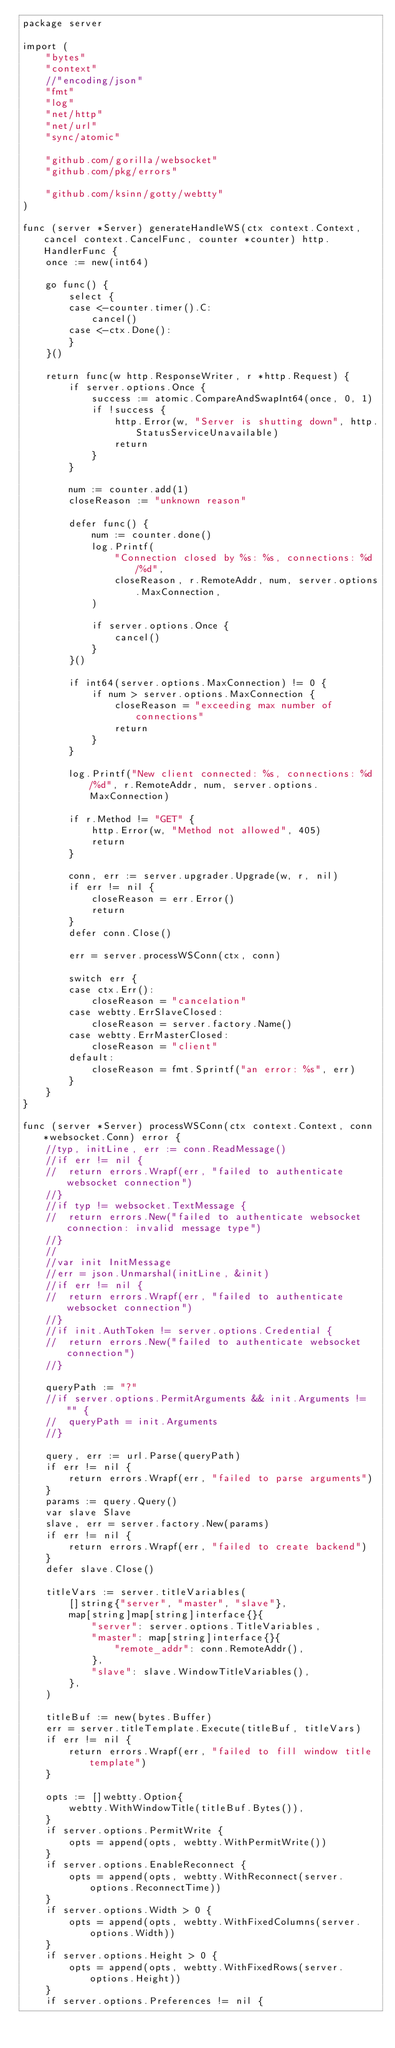Convert code to text. <code><loc_0><loc_0><loc_500><loc_500><_Go_>package server

import (
	"bytes"
	"context"
	//"encoding/json"
	"fmt"
	"log"
	"net/http"
	"net/url"
	"sync/atomic"

	"github.com/gorilla/websocket"
	"github.com/pkg/errors"

	"github.com/ksinn/gotty/webtty"
)

func (server *Server) generateHandleWS(ctx context.Context, cancel context.CancelFunc, counter *counter) http.HandlerFunc {
	once := new(int64)

	go func() {
		select {
		case <-counter.timer().C:
			cancel()
		case <-ctx.Done():
		}
	}()

	return func(w http.ResponseWriter, r *http.Request) {
		if server.options.Once {
			success := atomic.CompareAndSwapInt64(once, 0, 1)
			if !success {
				http.Error(w, "Server is shutting down", http.StatusServiceUnavailable)
				return
			}
		}

		num := counter.add(1)
		closeReason := "unknown reason"

		defer func() {
			num := counter.done()
			log.Printf(
				"Connection closed by %s: %s, connections: %d/%d",
				closeReason, r.RemoteAddr, num, server.options.MaxConnection,
			)

			if server.options.Once {
				cancel()
			}
		}()

		if int64(server.options.MaxConnection) != 0 {
			if num > server.options.MaxConnection {
				closeReason = "exceeding max number of connections"
				return
			}
		}

		log.Printf("New client connected: %s, connections: %d/%d", r.RemoteAddr, num, server.options.MaxConnection)

		if r.Method != "GET" {
			http.Error(w, "Method not allowed", 405)
			return
		}

		conn, err := server.upgrader.Upgrade(w, r, nil)
		if err != nil {
			closeReason = err.Error()
			return
		}
		defer conn.Close()

		err = server.processWSConn(ctx, conn)

		switch err {
		case ctx.Err():
			closeReason = "cancelation"
		case webtty.ErrSlaveClosed:
			closeReason = server.factory.Name()
		case webtty.ErrMasterClosed:
			closeReason = "client"
		default:
			closeReason = fmt.Sprintf("an error: %s", err)
		}
	}
}

func (server *Server) processWSConn(ctx context.Context, conn *websocket.Conn) error {
	//typ, initLine, err := conn.ReadMessage()
	//if err != nil {
	//	return errors.Wrapf(err, "failed to authenticate websocket connection")
	//}
	//if typ != websocket.TextMessage {
	//	return errors.New("failed to authenticate websocket connection: invalid message type")
	//}
	//
	//var init InitMessage
	//err = json.Unmarshal(initLine, &init)
	//if err != nil {
	//	return errors.Wrapf(err, "failed to authenticate websocket connection")
	//}
	//if init.AuthToken != server.options.Credential {
	//	return errors.New("failed to authenticate websocket connection")
	//}

	queryPath := "?"
	//if server.options.PermitArguments && init.Arguments != "" {
	//	queryPath = init.Arguments
	//}

	query, err := url.Parse(queryPath)
	if err != nil {
		return errors.Wrapf(err, "failed to parse arguments")
	}
	params := query.Query()
	var slave Slave
	slave, err = server.factory.New(params)
	if err != nil {
		return errors.Wrapf(err, "failed to create backend")
	}
	defer slave.Close()

	titleVars := server.titleVariables(
		[]string{"server", "master", "slave"},
		map[string]map[string]interface{}{
			"server": server.options.TitleVariables,
			"master": map[string]interface{}{
				"remote_addr": conn.RemoteAddr(),
			},
			"slave": slave.WindowTitleVariables(),
		},
	)

	titleBuf := new(bytes.Buffer)
	err = server.titleTemplate.Execute(titleBuf, titleVars)
	if err != nil {
		return errors.Wrapf(err, "failed to fill window title template")
	}

	opts := []webtty.Option{
		webtty.WithWindowTitle(titleBuf.Bytes()),
	}
	if server.options.PermitWrite {
		opts = append(opts, webtty.WithPermitWrite())
	}
	if server.options.EnableReconnect {
		opts = append(opts, webtty.WithReconnect(server.options.ReconnectTime))
	}
	if server.options.Width > 0 {
		opts = append(opts, webtty.WithFixedColumns(server.options.Width))
	}
	if server.options.Height > 0 {
		opts = append(opts, webtty.WithFixedRows(server.options.Height))
	}
	if server.options.Preferences != nil {</code> 